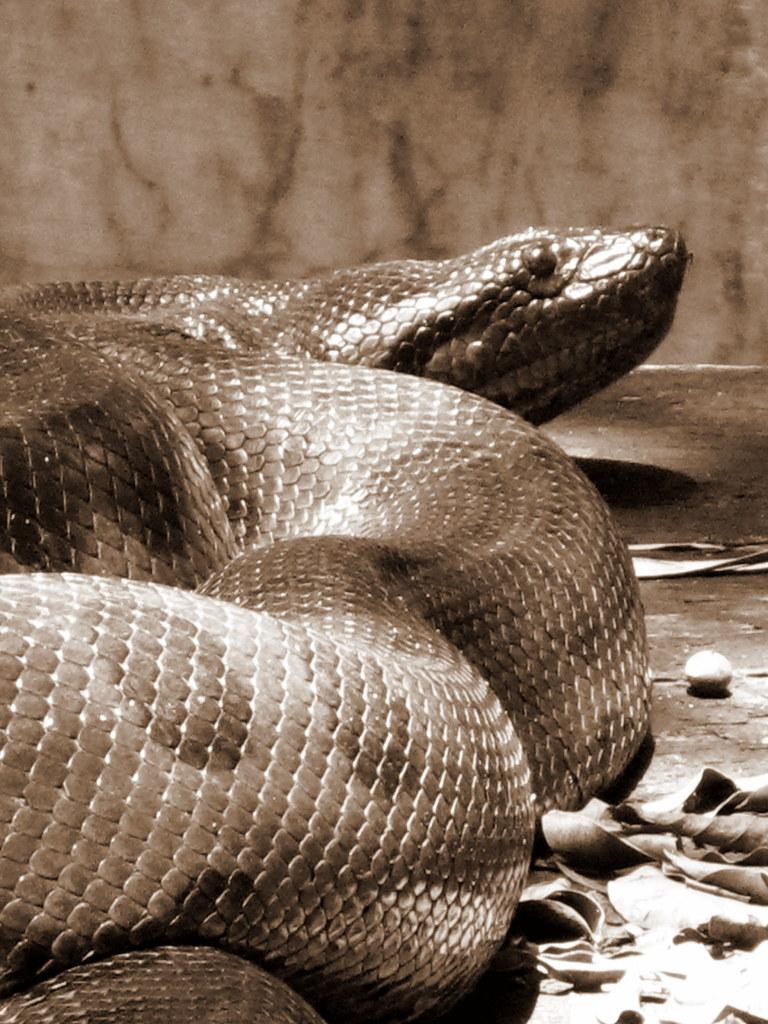Can you describe this image briefly? In this image we can see snake on the ground. On the left side there are leaves. 